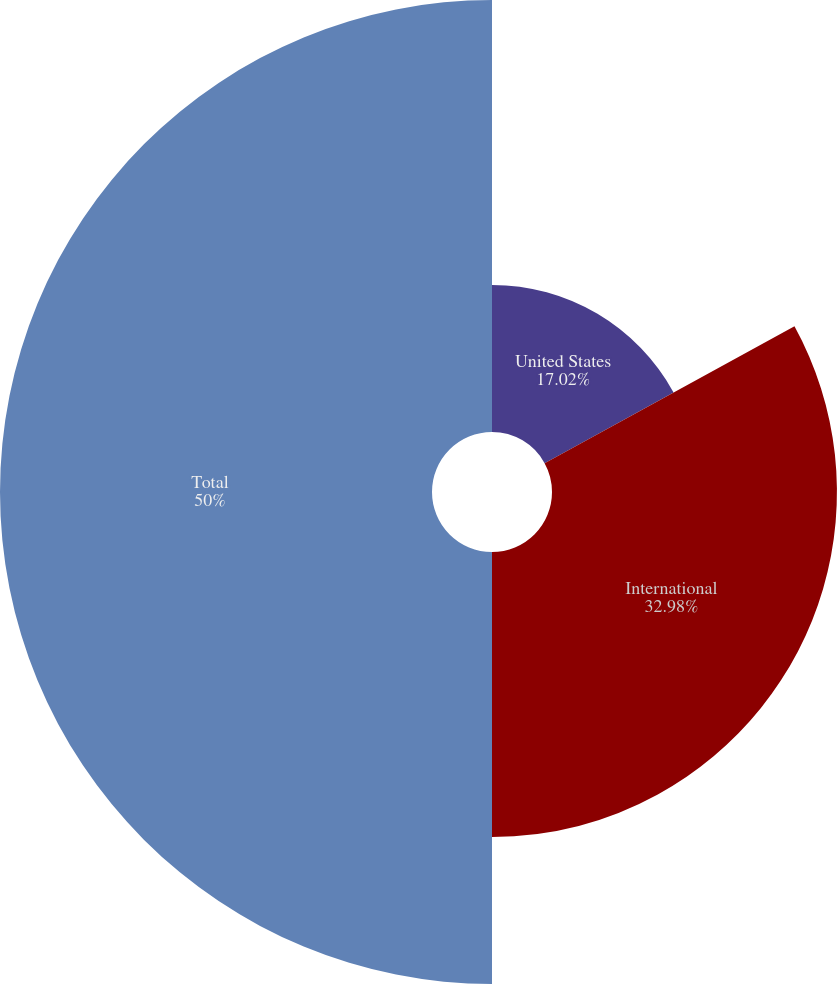Convert chart to OTSL. <chart><loc_0><loc_0><loc_500><loc_500><pie_chart><fcel>United States<fcel>International<fcel>Total<nl><fcel>17.02%<fcel>32.98%<fcel>50.0%<nl></chart> 